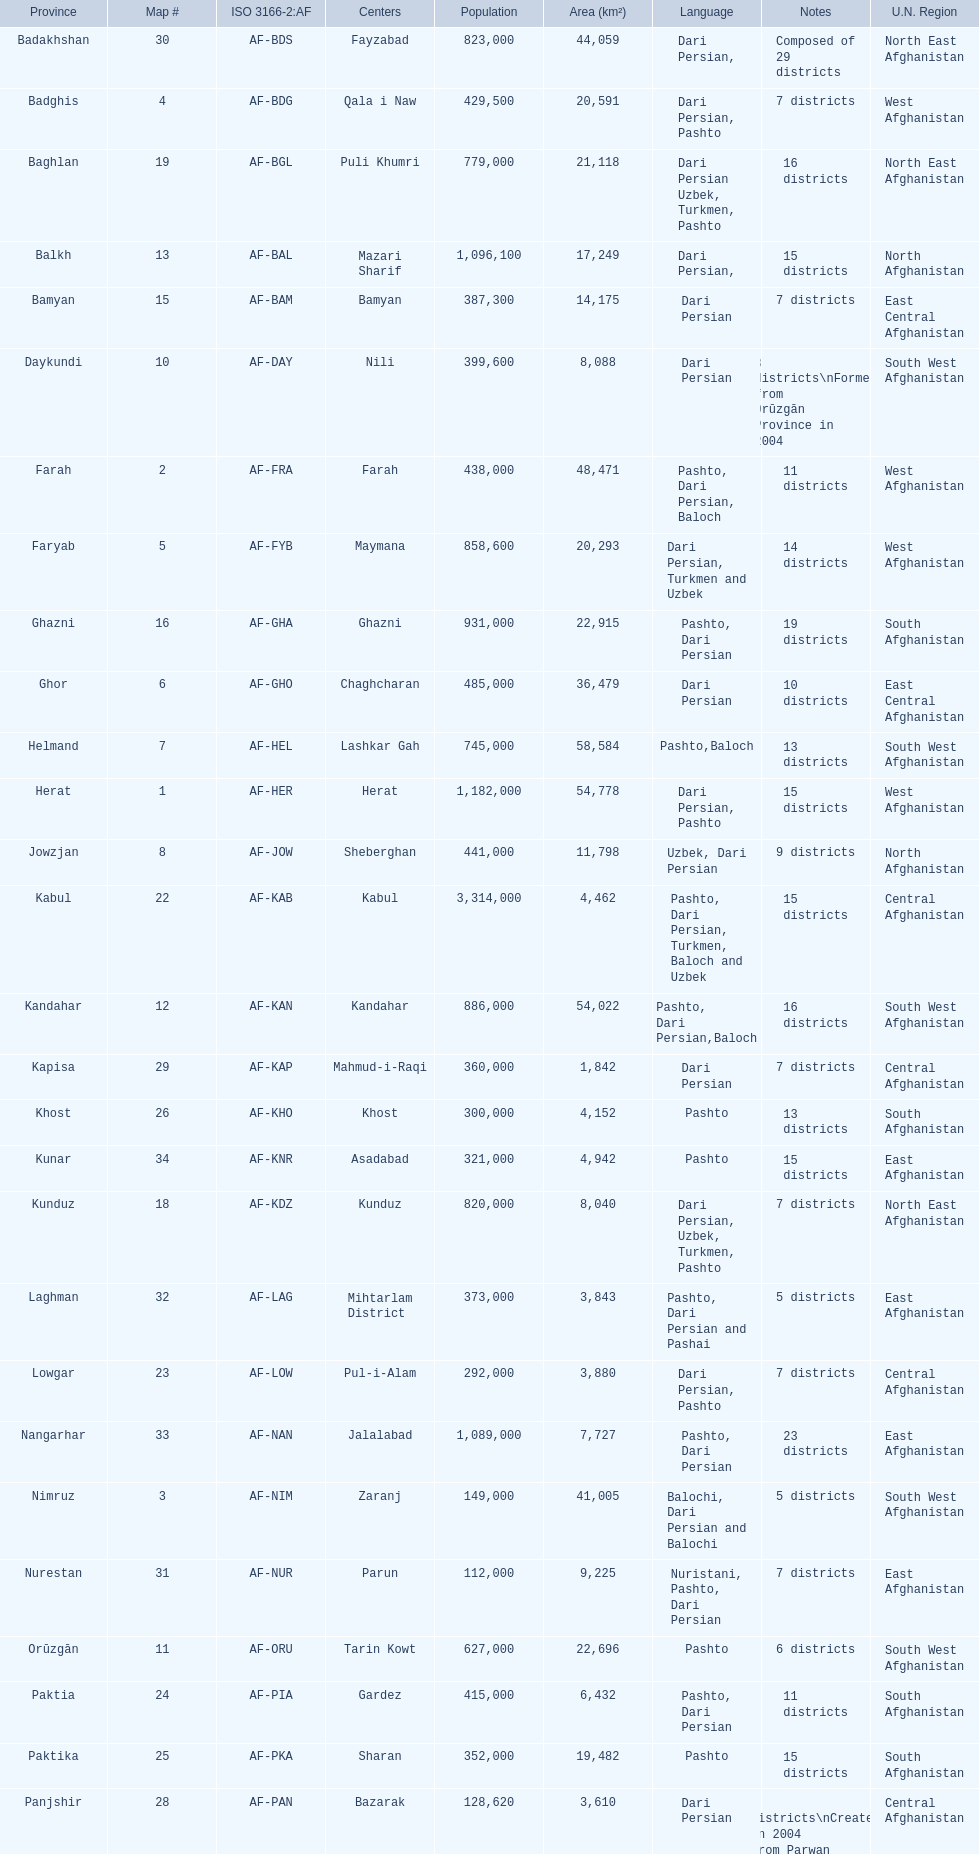Which has a greater number of districts, ghor or farah? Farah. 